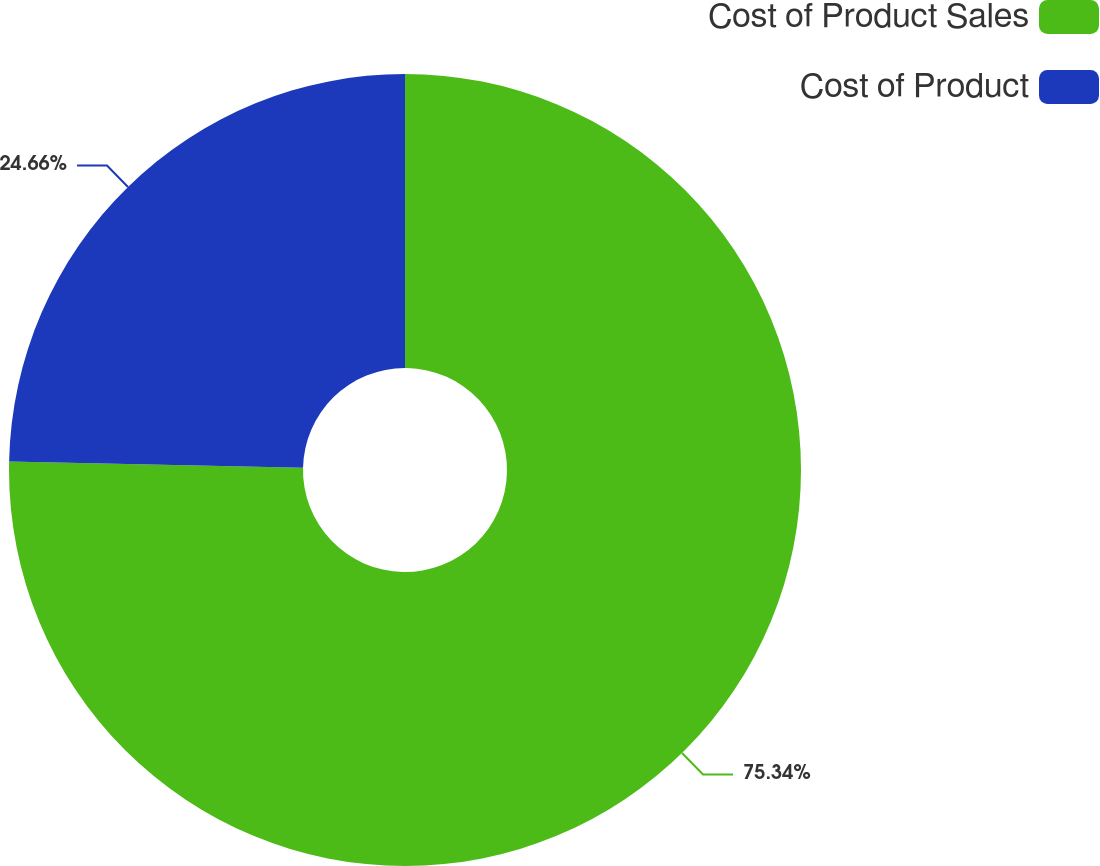Convert chart to OTSL. <chart><loc_0><loc_0><loc_500><loc_500><pie_chart><fcel>Cost of Product Sales<fcel>Cost of Product<nl><fcel>75.34%<fcel>24.66%<nl></chart> 